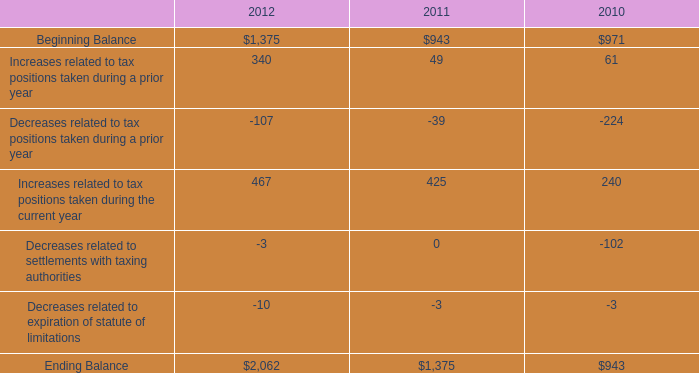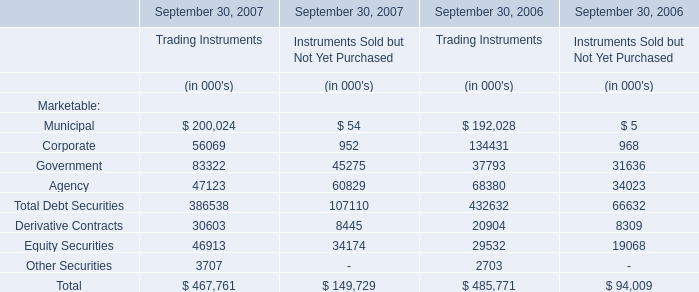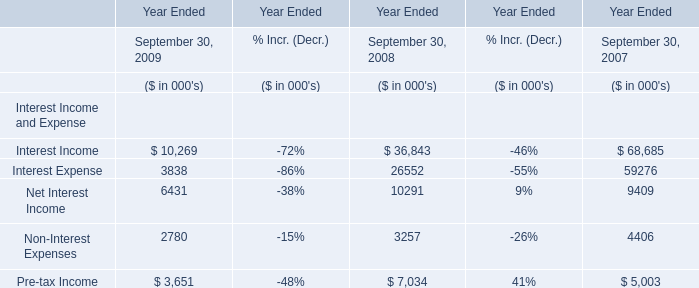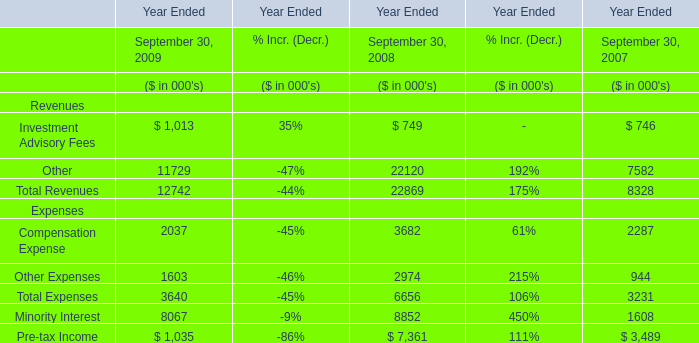What will other expenses reach in 2010 if it continues to grow at its current rate? (in thousand) 
Computations: ((((1603 - 2974) / 2974) + 1) * 1603)
Answer: 864.02455. 